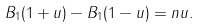Convert formula to latex. <formula><loc_0><loc_0><loc_500><loc_500>B _ { 1 } ( 1 + u ) - B _ { 1 } ( 1 - u ) = n u .</formula> 